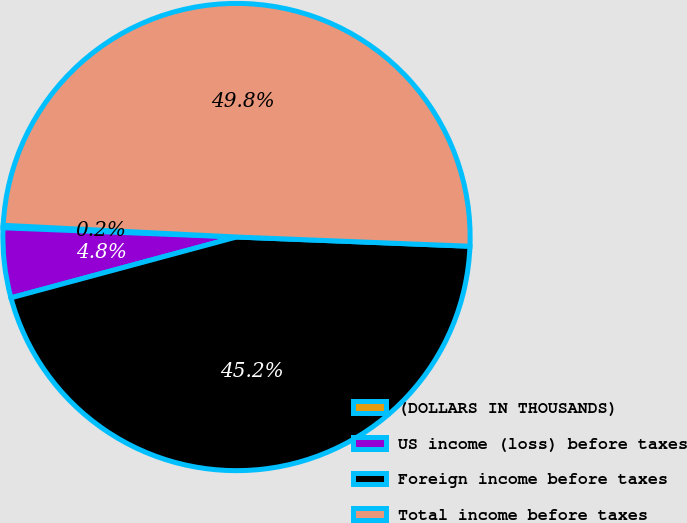Convert chart. <chart><loc_0><loc_0><loc_500><loc_500><pie_chart><fcel>(DOLLARS IN THOUSANDS)<fcel>US income (loss) before taxes<fcel>Foreign income before taxes<fcel>Total income before taxes<nl><fcel>0.17%<fcel>4.82%<fcel>45.18%<fcel>49.83%<nl></chart> 